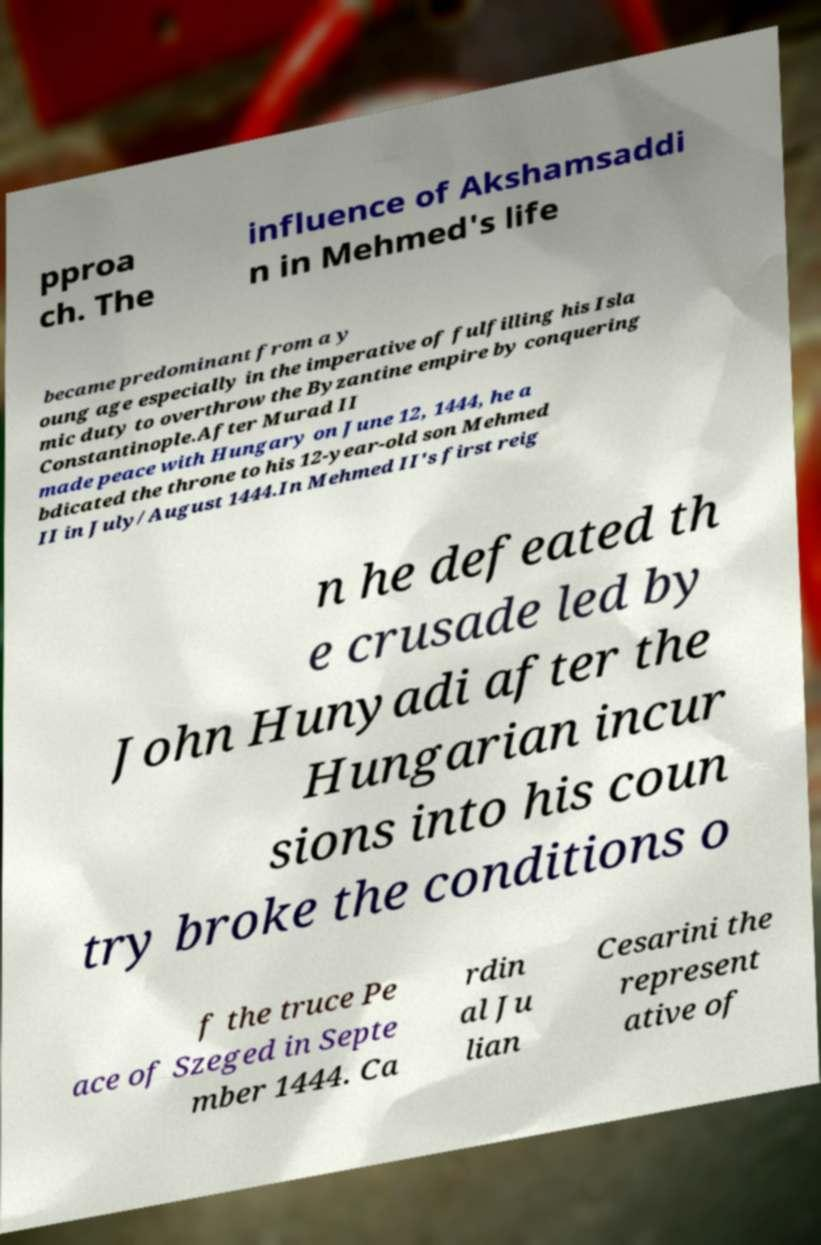Please identify and transcribe the text found in this image. pproa ch. The influence of Akshamsaddi n in Mehmed's life became predominant from a y oung age especially in the imperative of fulfilling his Isla mic duty to overthrow the Byzantine empire by conquering Constantinople.After Murad II made peace with Hungary on June 12, 1444, he a bdicated the throne to his 12-year-old son Mehmed II in July/August 1444.In Mehmed II's first reig n he defeated th e crusade led by John Hunyadi after the Hungarian incur sions into his coun try broke the conditions o f the truce Pe ace of Szeged in Septe mber 1444. Ca rdin al Ju lian Cesarini the represent ative of 